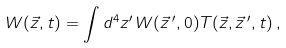Convert formula to latex. <formula><loc_0><loc_0><loc_500><loc_500>W ( \vec { z } , t ) = \int d ^ { 4 } z ^ { \prime } \, W ( \vec { z } \, ^ { \prime } , 0 ) T ( \vec { z } , \vec { z } \, ^ { \prime } , t ) \, ,</formula> 